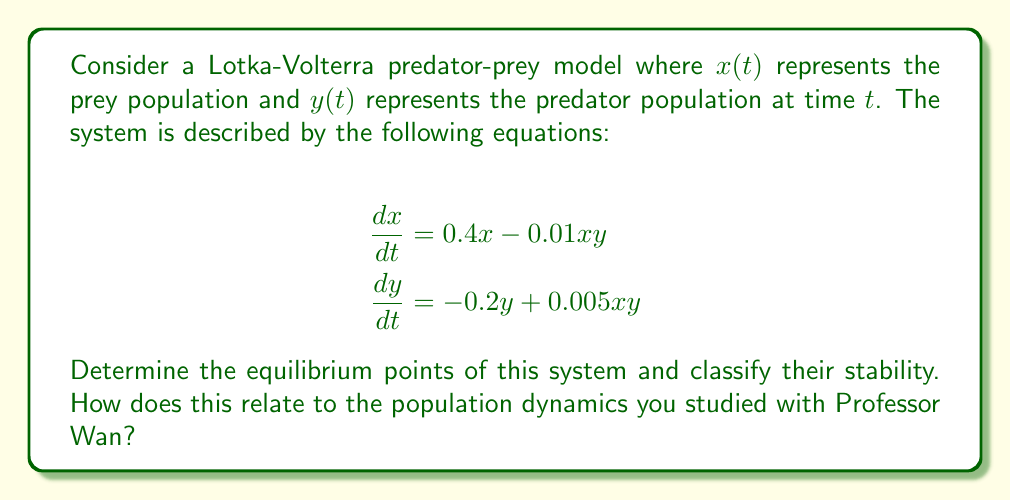Solve this math problem. To solve this problem, we'll follow these steps:

1) Find the equilibrium points by setting both equations equal to zero and solving for $x$ and $y$.

2) Analyze the stability of each equilibrium point using the Jacobian matrix.

Step 1: Finding equilibrium points

Set both equations to zero:

$$0.4x - 0.01xy = 0$$
$$-0.2y + 0.005xy = 0$$

From the first equation:
$$x(0.4 - 0.01y) = 0$$
So either $x = 0$ or $y = 40$

From the second equation:
$$y(-0.2 + 0.005x) = 0$$
So either $y = 0$ or $x = 40$

This gives us two equilibrium points:
(0, 0) and (40, 40)

Step 2: Stability analysis

The Jacobian matrix for this system is:

$$J = \begin{bmatrix}
0.4 - 0.01y & -0.01x \\
0.005y & -0.2 + 0.005x
\end{bmatrix}$$

For the equilibrium point (0, 0):

$$J_{(0,0)} = \begin{bmatrix}
0.4 & 0 \\
0 & -0.2
\end{bmatrix}$$

The eigenvalues are 0.4 and -0.2. Since one eigenvalue is positive, this equilibrium point is unstable (a saddle point).

For the equilibrium point (40, 40):

$$J_{(40,40)} = \begin{bmatrix}
0 & -0.4 \\
0.2 & 0
\end{bmatrix}$$

The eigenvalues are $\pm 0.2i$. Since both eigenvalues are purely imaginary, this equilibrium point is a center, indicating neutral stability.

This analysis shows that the origin is an unstable equilibrium, while the point (40, 40) represents a state of coexistence between predator and prey populations. The system will oscillate around this point, demonstrating the cyclic nature of predator-prey interactions that Professor Wan likely emphasized in his lectures on population dynamics.
Answer: The system has two equilibrium points: (0, 0) and (40, 40). The origin (0, 0) is an unstable saddle point, while (40, 40) is a center with neutral stability, around which the populations will oscillate. 